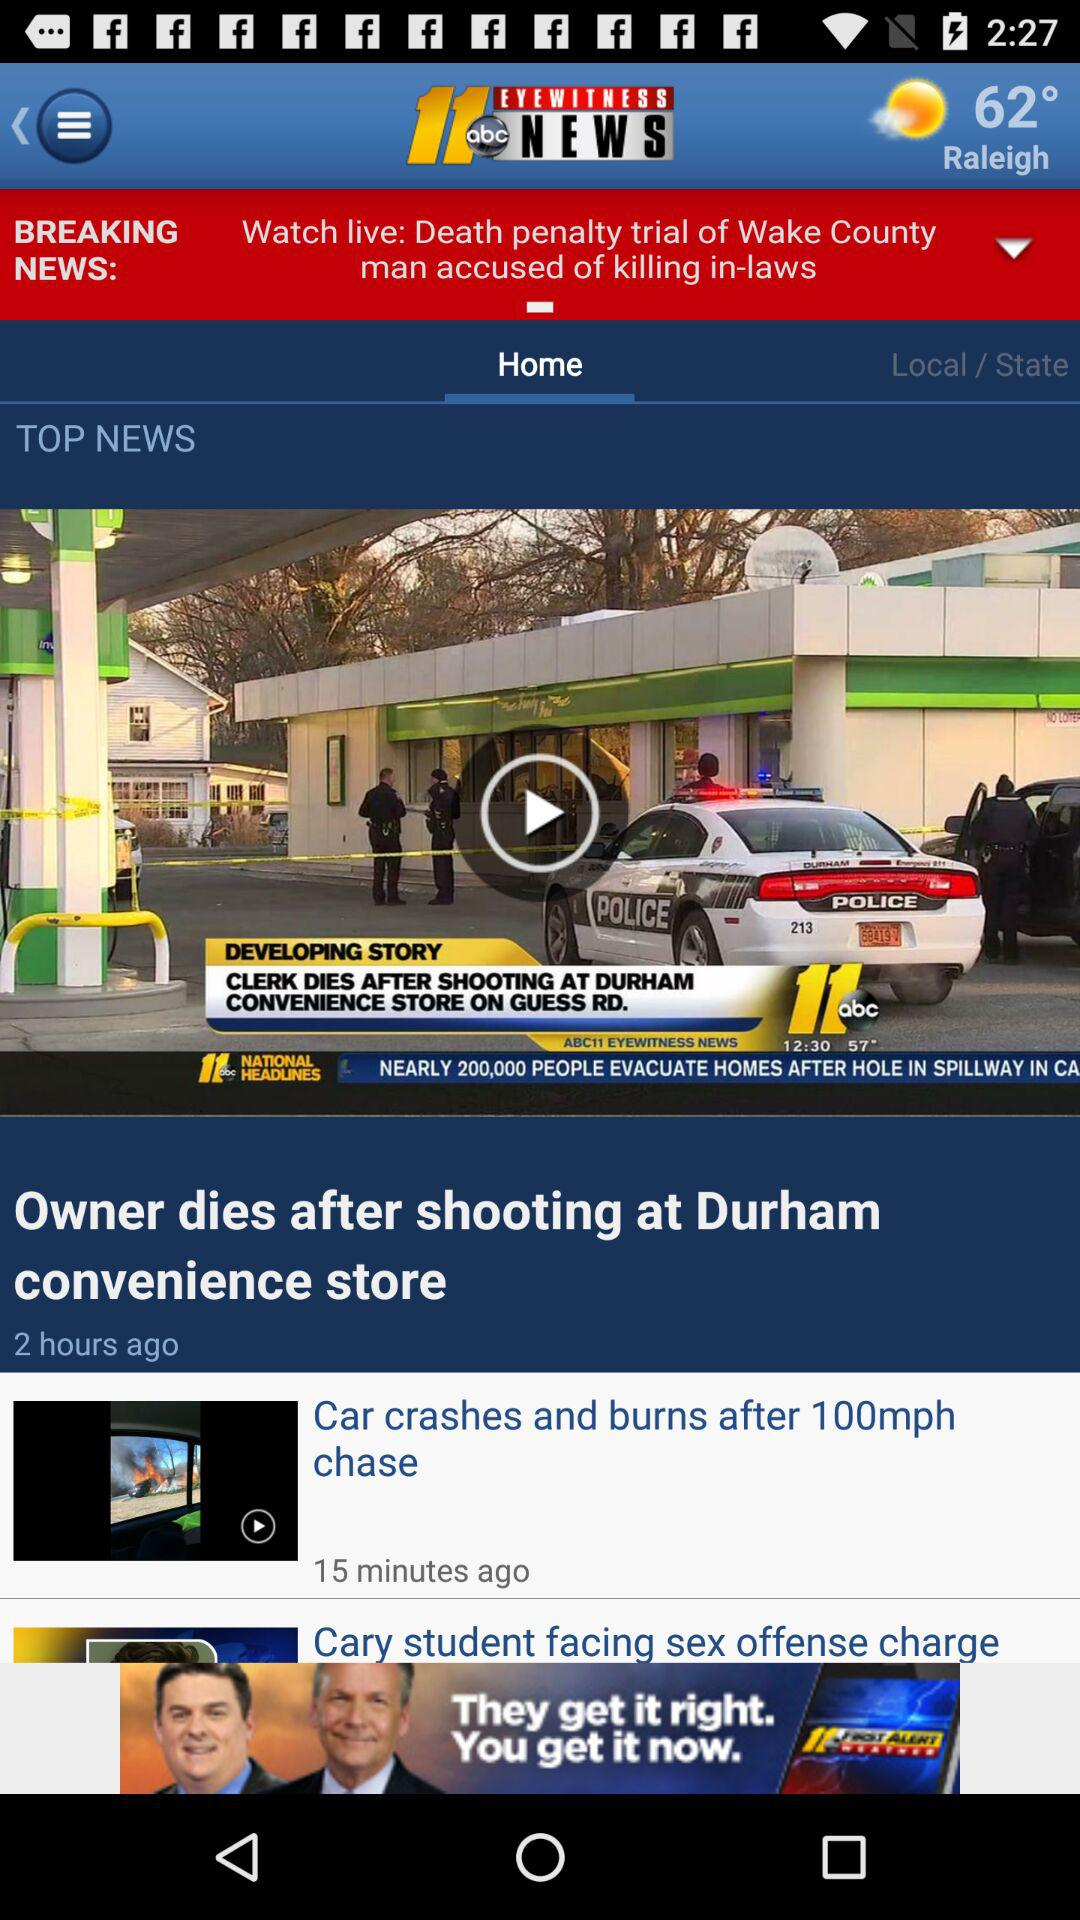Which tab is selected? The selected tab is "Home". 